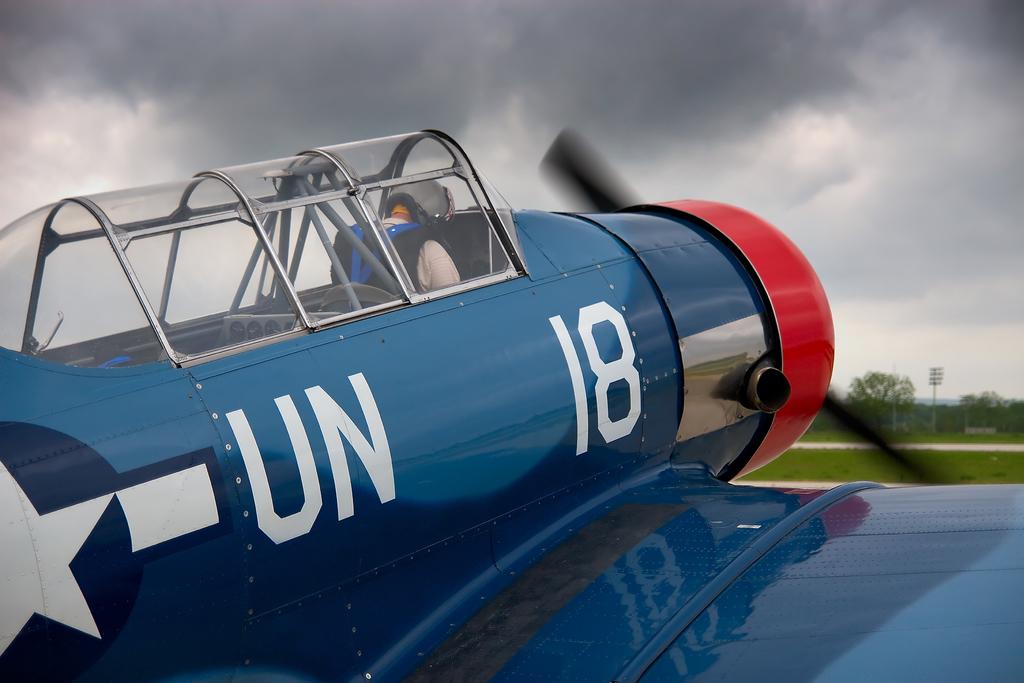What number is the plane?
Ensure brevity in your answer.  18. 